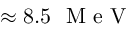<formula> <loc_0><loc_0><loc_500><loc_500>\approx 8 . 5 M e V</formula> 